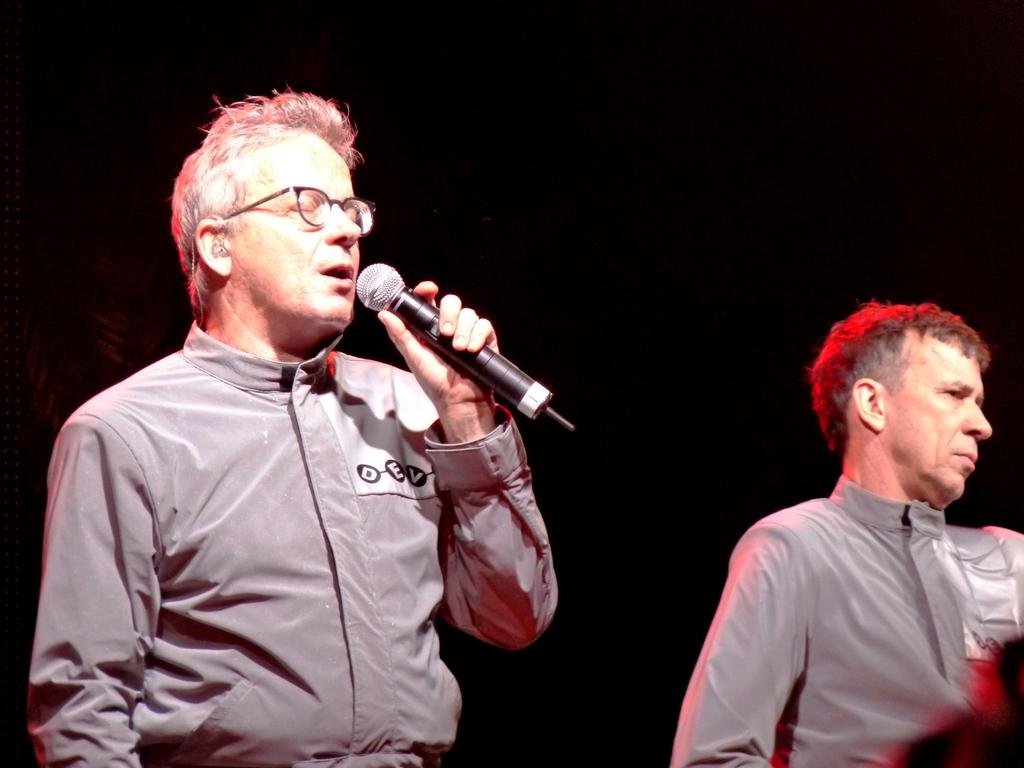How many people are in the image? There are two men in the image. What is one of the men holding? One man is holding a microphone. What is the man with the microphone doing? The man with the microphone is speaking. What can be observed about the background of the image? The background of the image is dark. What type of pest is visible in the image? There is no pest present in the image. What country is the expert in the image from? There is no expert or country mentioned in the image. 